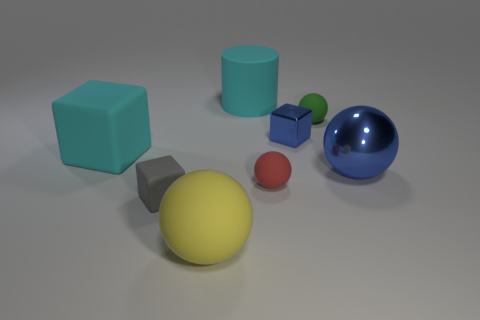What number of green objects are the same size as the blue cube? There is one green cube that is the same size as the blue cube. It's positioned between the yellow sphere and the larger blue sphere and has an identical appearance in size and shape to the blue cube, differentiating only in color. 